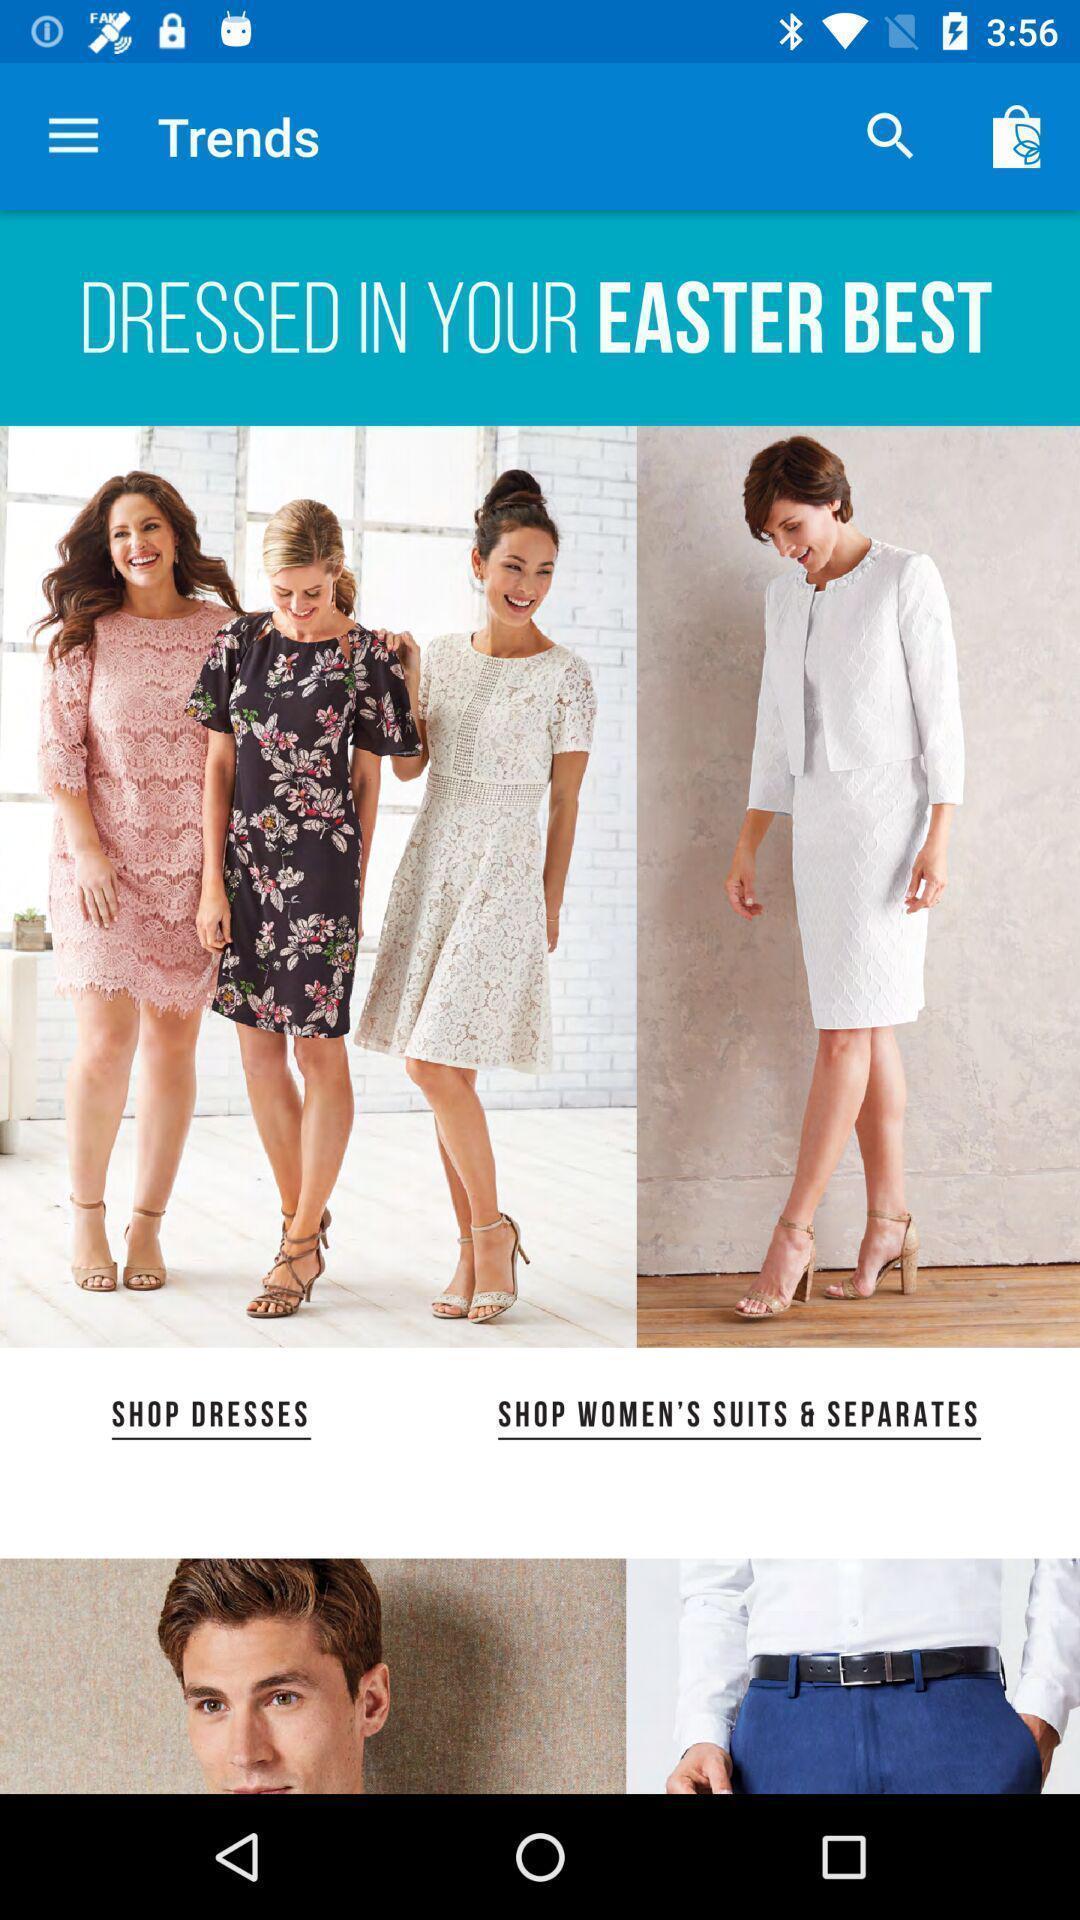Describe the key features of this screenshot. Screen displaying multiple options in a shopping application. 